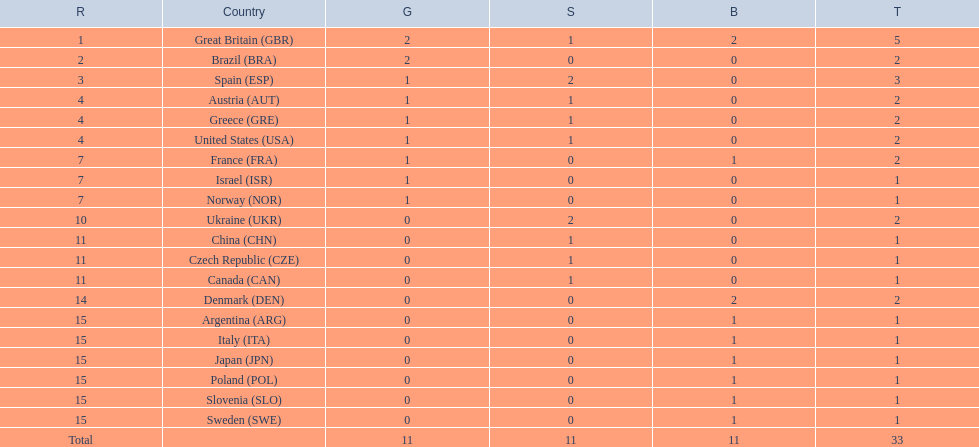Which nation received 2 silver medals? Spain (ESP), Ukraine (UKR). Of those, which nation also had 2 total medals? Spain (ESP). 